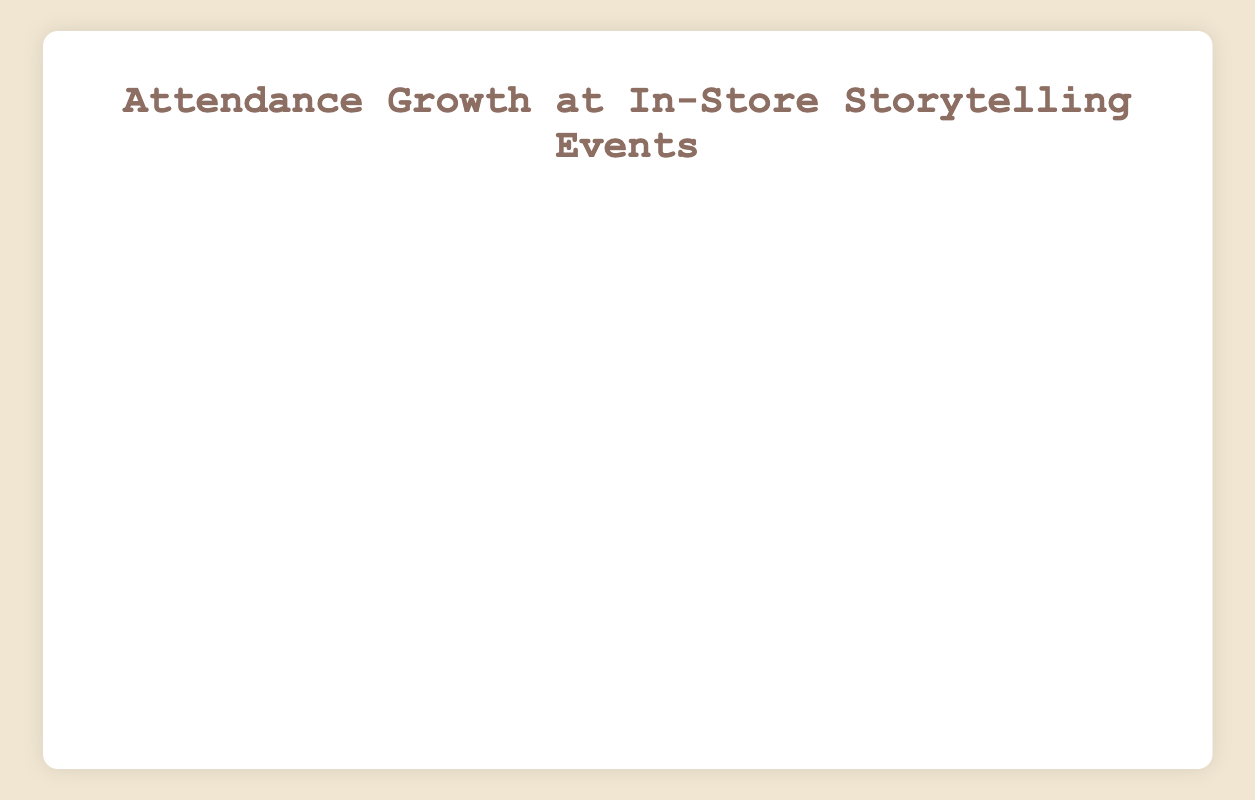What is the attendance growth from the first event to the last event in the plot? First, find the attendance at the first event on 2022-01-05, which is 20. Then, find the attendance at the last event on 2023-03-15, which is 240. The growth is 240 - 20 = 220.
Answer: 220 Which event had the highest attendance and what was the value? Scan the plot for the peak point in the curve. For 2022-12-21 "Holiday Tales" event, the attendance was 170, and it was surpassed by 2023-03-15 "Classic Literature" with 240.
Answer: Classic Literature, 240 Between which two consecutive events was the largest increase in attendance? Identify the segments in the plot where the increase between two consecutive points is the highest. The largest increase is from "Children's Tales" (70) on 2022-04-20 to "Romantic Stories" (80) on 2022-05-18, a difference of 10 which is repeatedly exceeded by an increase from "New Year Stories" (180) on 2022-12-21 to "Fairytales Evening" (190) on 2023-01-04.
Answer: New Year Stories to Fairytales Evening Which event in 2022 had the lowest attendance? Find the minimum attendance value for events in 2022. "Fairytales Evening" on 2022-01-05 had the lowest attendance of 20.
Answer: Fairytales Evening How many events had an attendance of over 100? Count the number of plot points above the attendance value of 100. The events are:
1. Greek Myths
2. Epic Narratives
3. Folklore Favourites
4. Magical Realism
5. Victorian Classics
6. Science Fiction Epics
7. Holiday Tales
8. New Year Stories
9. Fairytales Evening (in 2023)
10. Mystery Night (in 2023)
11. Historical Tales (in 2023)
12. Fantasy Adventures (in 2023)
13. Sci-Fi Stories (in 2023)
14. Classic Literature (in 2023)
So, there are 14 events
Answer: 14 By how much did the attendance increase on average per month? First, count the number of months from 2022-01-05 to 2023-03-15 which is 15. Calculate the total attendance increase from 20 to 240, resulting in 220. Then, divide the total increase by the number of months: 220 / 15 = 14.67.
Answer: 14.67 Which event saw the largest decline in attendance compared to the previous event? Look for the steepest downward slope in the plot. The largest decline is from "Classic Literature" (2022-03-16, 60) to "Modern Drama" (2022-04-06, 55) with a decline of 5.
Answer: Classic Literature to Modern Drama What is the total attendance for events in March 2023? Find the attendance of events in March 2023:
1. Sci-Fi Stories (2023-03-01): 230
2. Classic Literature (2023-03-15): 240 
Total = 230 + 240 = 470.
Answer: 470 